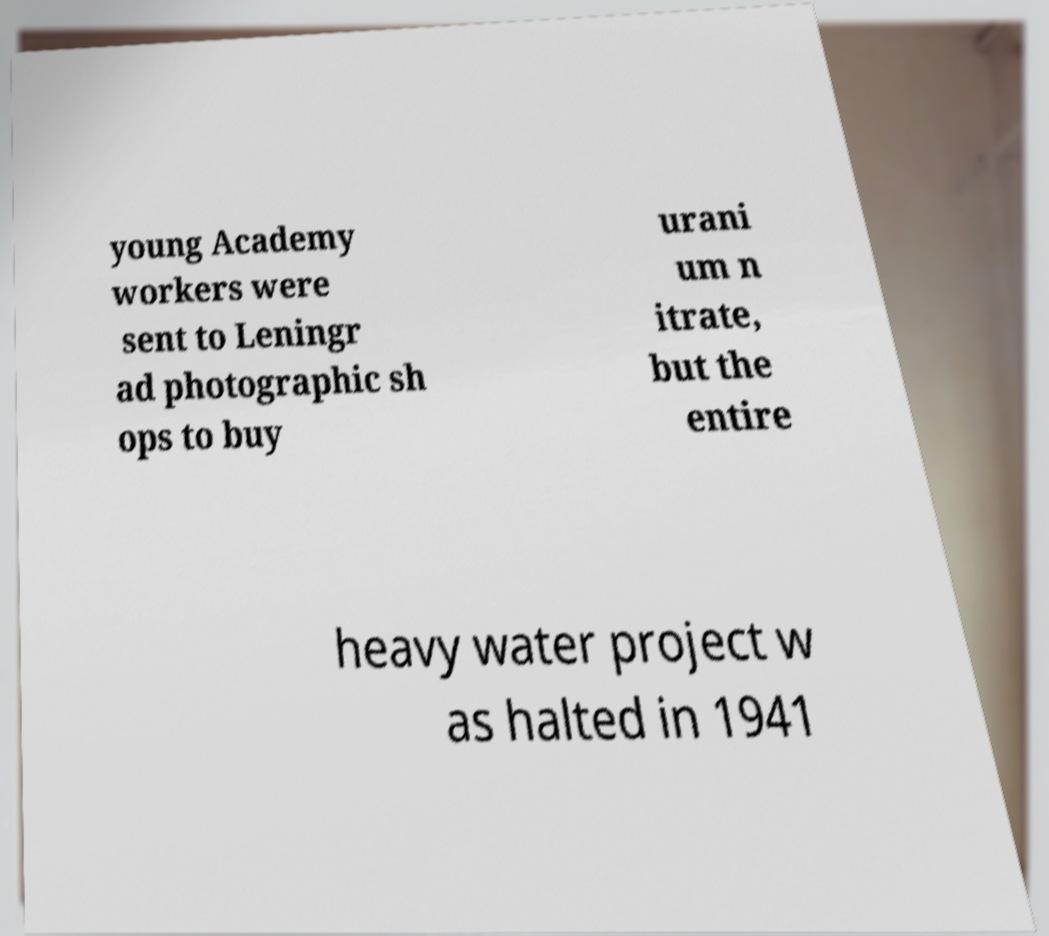Can you read and provide the text displayed in the image?This photo seems to have some interesting text. Can you extract and type it out for me? young Academy workers were sent to Leningr ad photographic sh ops to buy urani um n itrate, but the entire heavy water project w as halted in 1941 